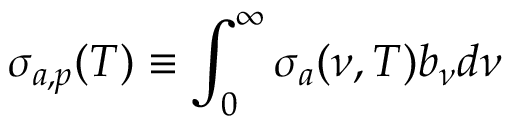Convert formula to latex. <formula><loc_0><loc_0><loc_500><loc_500>\sigma _ { a , p } ( T ) \equiv \int _ { 0 } ^ { \infty } \sigma _ { a } ( \nu , T ) b _ { \nu } d \nu</formula> 